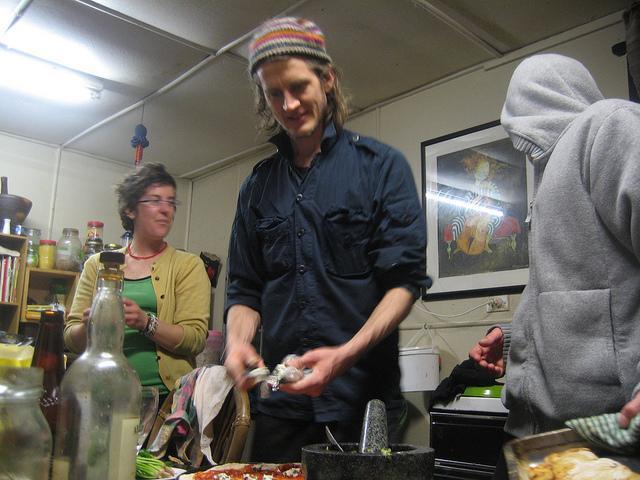How many pizzas are there?
Give a very brief answer. 1. How many ovens are there?
Give a very brief answer. 1. How many people are in the photo?
Give a very brief answer. 3. How many bottles are there?
Give a very brief answer. 3. How many black railroad cars are at the train station?
Give a very brief answer. 0. 